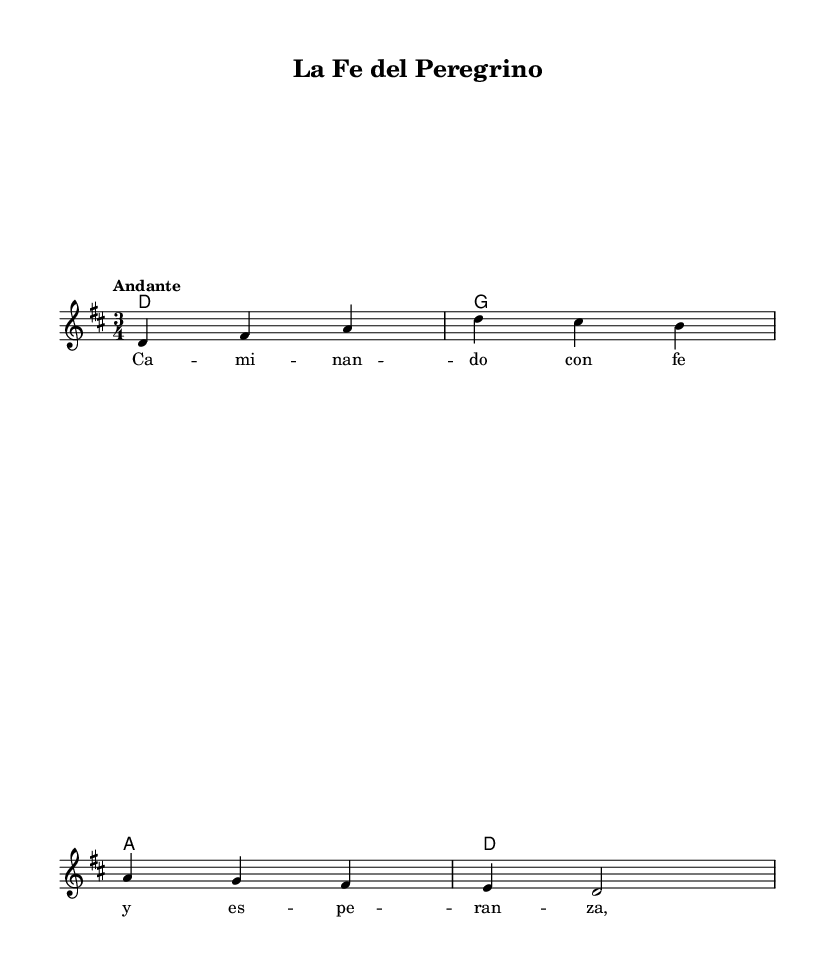What is the key signature of this music? The key signature is D major, which contains two sharps (F# and C#). You can identify the key signature by looking at the beginning of the staff, where the sharps are indicated.
Answer: D major What is the time signature of this music? The time signature is 3/4, indicating three beats per measure and a quarter note receives one beat. You can determine the time signature by examining the numbers at the beginning of the staff.
Answer: 3/4 What is the tempo marking of this piece? The tempo marking is "Andante," which means at a moderate pace, generally slower than allegro but faster than adagio. You can find the tempo indication in the notation, usually placed above the staff.
Answer: Andante How many measures are in the melody section? There are four measures in the melody section, which can be counted by examining the notations between the barlines present in the staff.
Answer: 4 What is the first note in the melody? The first note in the melody is D. You can identify this by looking at the first note of the melody staff.
Answer: D Which chord follows the first measure in the harmonies? The chord following the first measure is G major. Looking at the chord symbols above the staff, the first measure has a D major chord and the second an G major.
Answer: G What is the lyrical theme of the song? The lyrical theme revolves around faith and hope, as indicated by the lyrics starting with "Ca-mi-nan-do con fe y es-pe-ran-za," which translates to "Walking with faith and hope." The title and the lyrics suggest a deep spiritual meaning linked to a journey of faith.
Answer: Faith and hope 